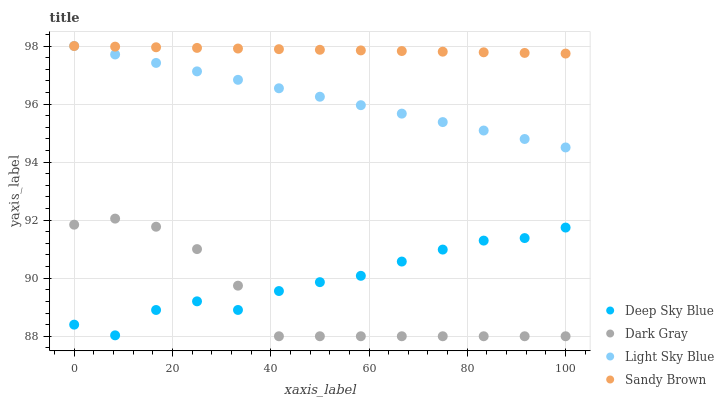Does Dark Gray have the minimum area under the curve?
Answer yes or no. Yes. Does Sandy Brown have the maximum area under the curve?
Answer yes or no. Yes. Does Light Sky Blue have the minimum area under the curve?
Answer yes or no. No. Does Light Sky Blue have the maximum area under the curve?
Answer yes or no. No. Is Sandy Brown the smoothest?
Answer yes or no. Yes. Is Deep Sky Blue the roughest?
Answer yes or no. Yes. Is Light Sky Blue the smoothest?
Answer yes or no. No. Is Light Sky Blue the roughest?
Answer yes or no. No. Does Dark Gray have the lowest value?
Answer yes or no. Yes. Does Light Sky Blue have the lowest value?
Answer yes or no. No. Does Sandy Brown have the highest value?
Answer yes or no. Yes. Does Deep Sky Blue have the highest value?
Answer yes or no. No. Is Dark Gray less than Sandy Brown?
Answer yes or no. Yes. Is Light Sky Blue greater than Deep Sky Blue?
Answer yes or no. Yes. Does Light Sky Blue intersect Sandy Brown?
Answer yes or no. Yes. Is Light Sky Blue less than Sandy Brown?
Answer yes or no. No. Is Light Sky Blue greater than Sandy Brown?
Answer yes or no. No. Does Dark Gray intersect Sandy Brown?
Answer yes or no. No. 